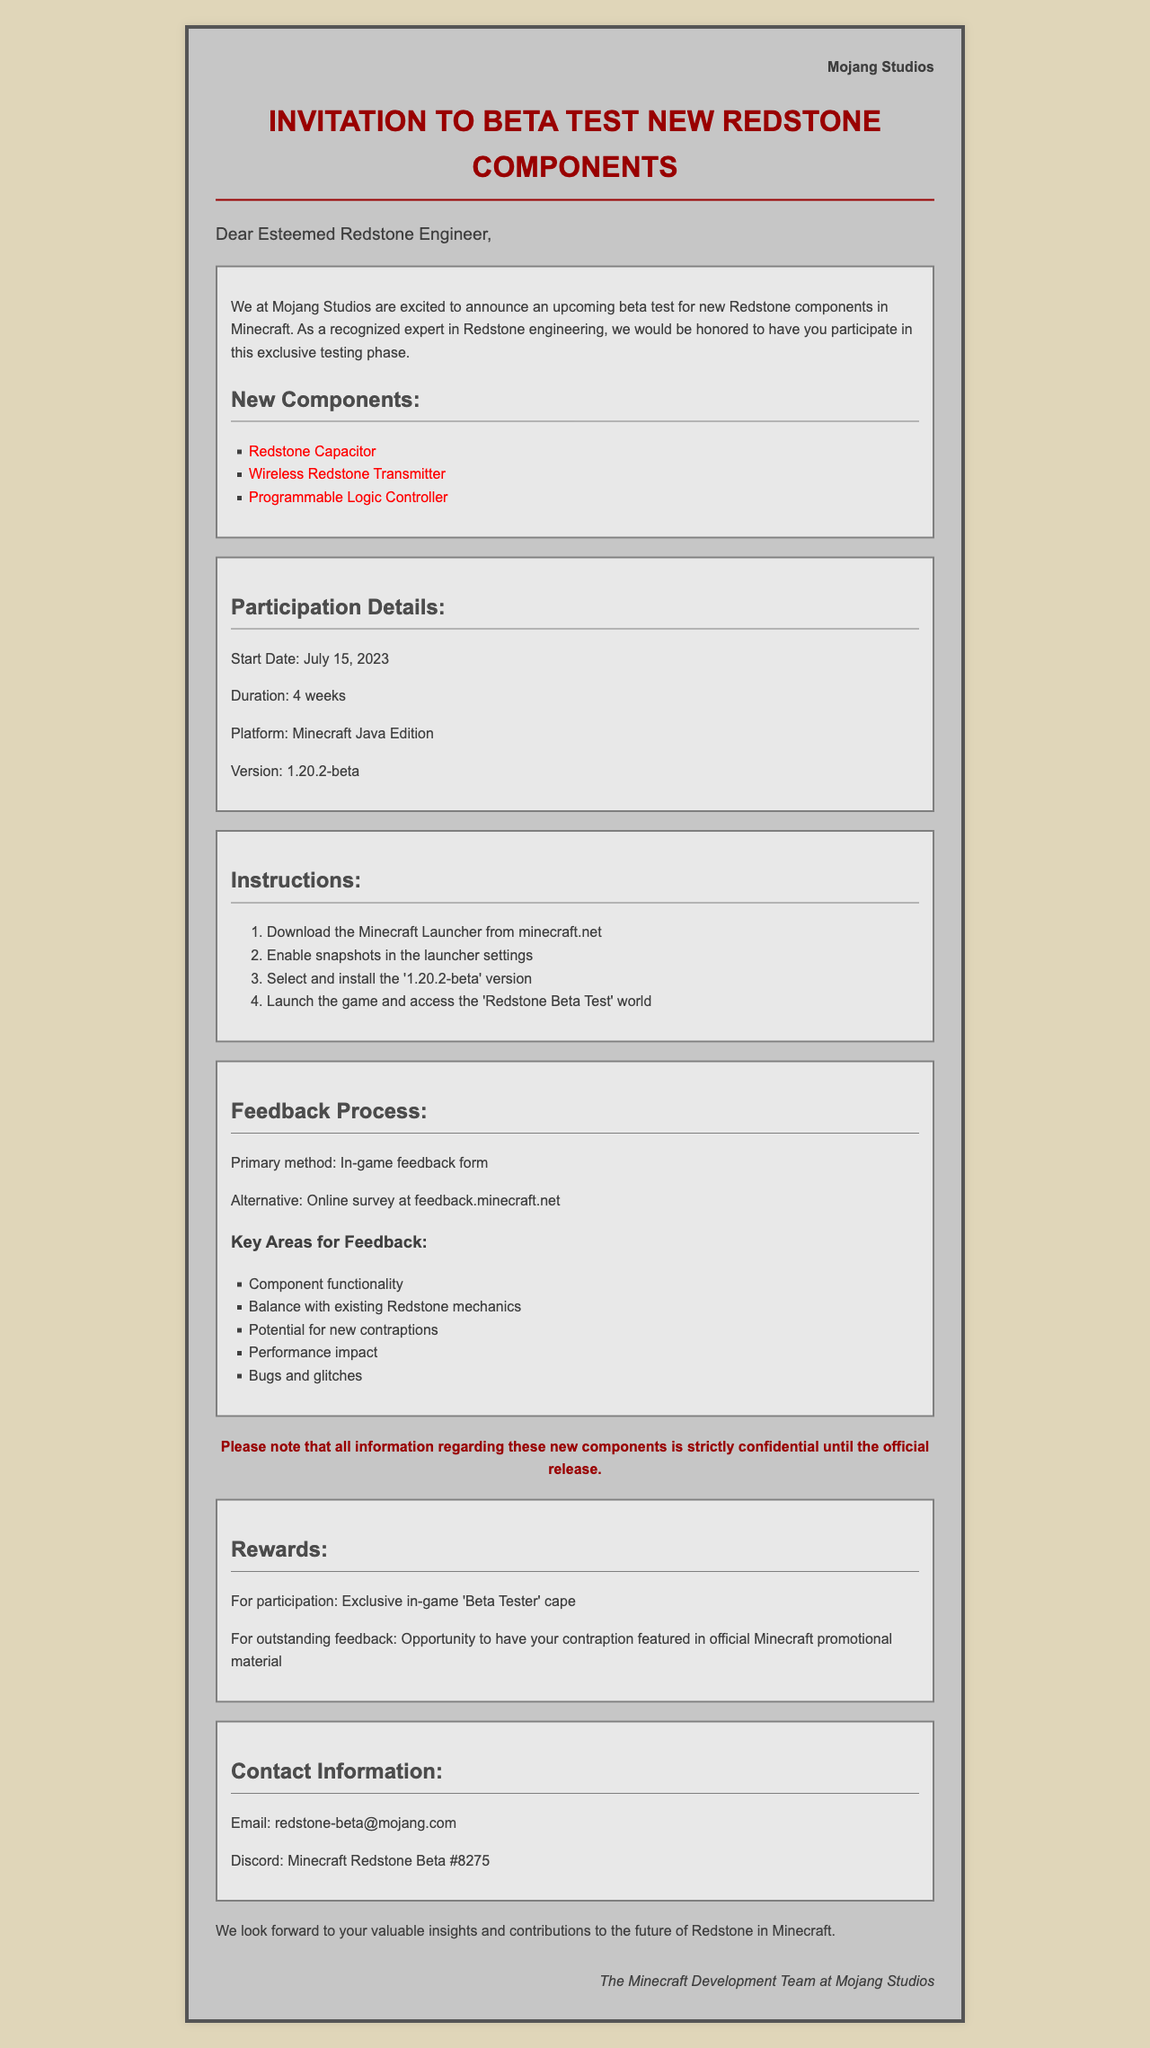What is the sender of the letter? The sender is the organization behind the invitation.
Answer: Mojang Studios What is the starting date for the beta test? The starting date is a key detail provided in the participation section.
Answer: July 15, 2023 How long is the duration of the beta test? The duration describes how long the testing phase will last.
Answer: 4 weeks What is one of the new Redstone components introduced? The introduction highlights new components being tested.
Answer: Wireless Redstone Transmitter What method is used for providing feedback during the beta test? The document specifies the primary method for feedback.
Answer: In-game feedback form What is the reward for participating in the beta test? The rewards section outlines incentives for participants.
Answer: Exclusive in-game 'Beta Tester' cape What platform is required for the beta test? This information identifies the specific platform needed to participate.
Answer: Minecraft Java Edition How can participants access the feedback process? This illustrates the method of feedback collection in detail.
Answer: Online survey at feedback.minecraft.net What is the confidentiality statement regarding the new components? The confidentiality note emphasizes the seriousness of information sharing.
Answer: strictly confidential until the official release 